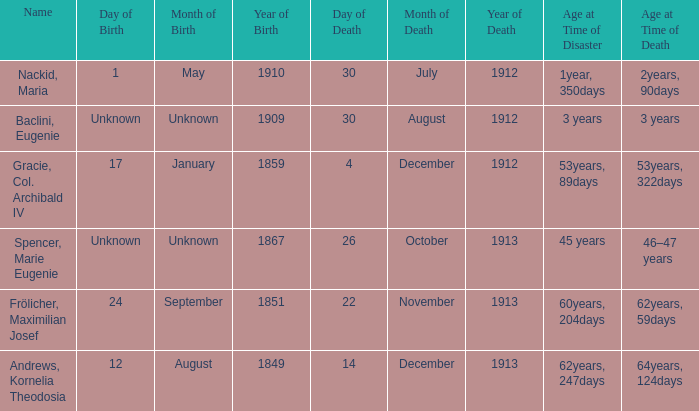How old was the person born 24 September 1851 at the time of disaster? 60years, 204days. 